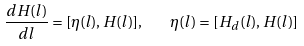Convert formula to latex. <formula><loc_0><loc_0><loc_500><loc_500>\frac { d H ( l ) } { d l } = [ \eta ( l ) , H ( l ) ] , \quad \eta ( l ) = [ H _ { d } ( l ) , H ( l ) ]</formula> 